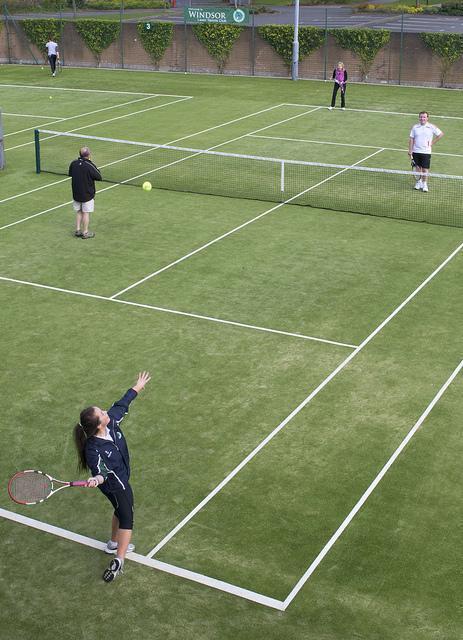What is the minimum number of players who can partake in a match of this sport?
Make your selection from the four choices given to correctly answer the question.
Options: Eight, four, two, three. Two. 